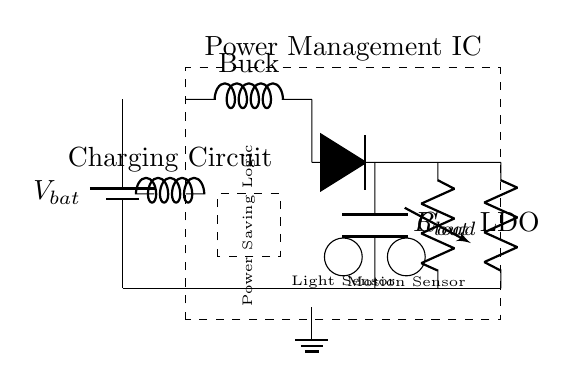What type of battery is represented in the circuit? The circuit diagram shows a generic battery symbol, typically representing a direct current (DC) battery that supplies voltage; it is labeled as V_bat.
Answer: Battery What components are included in the power management circuit? This circuit contains a battery, power management IC, buck converter, voltage regulator (LDO), load resistor, charging circuit, ambient light sensor, motion sensor, and power saving logic.
Answer: Eight How does the circuit manage charging? The charging mechanism is facilitated by the connection between the battery and the charging circuit, represented in the circuit as a cute inductor, which regulates the current flowing into the battery during charging.
Answer: Inductor Which sensors are used for managing power savings? The circuit includes two types of sensors: an ambient light sensor and a motion sensor, which contribute to the power management strategy by adjusting the power consumption based on environmental factors.
Answer: Two What is the function of the LDO in this circuit? The Low Dropout Regulator (LDO) takes input from the buck converter and provides a stable output voltage to the load, ensuring that the device operates efficiently without excessive power loss.
Answer: Voltage regulation How does the buck converter contribute to battery life? The buck converter steps down the voltage from the battery to a lower level suitable for the load while increasing the current, resulting in reduced power waste and extending battery life in energy-demanding situations.
Answer: Voltage step-down What role does the power saving logic play in this circuit? The power saving logic monitors input from the light and motion sensors to make real-time decisions on power consumption levels, allowing the circuit to reduce energy use when not actively engaged, thus extending battery life.
Answer: Energy management 